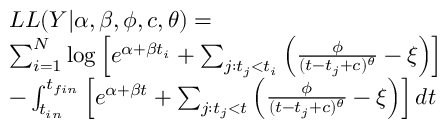Convert formula to latex. <formula><loc_0><loc_0><loc_500><loc_500>\begin{array} { r l } & { L L ( Y | \alpha , \beta , \phi , c , \theta ) = } \\ & { \sum _ { i = 1 } ^ { N } \log \left [ e ^ { \alpha + \beta t _ { i } } + \sum _ { j \colon t _ { j } < t _ { i } } \left ( \frac { \phi } { ( t - t _ { j } + c ) ^ { \theta } } - \xi \right ) \right ] } \\ & { - \int _ { t _ { i n } } ^ { t _ { f i n } } \left [ e ^ { \alpha + \beta t } + \sum _ { j \colon t _ { j } < t } \left ( \frac { \phi } { ( t - t _ { j } + c ) ^ { \theta } } - \xi \right ) \right ] d t } \end{array}</formula> 